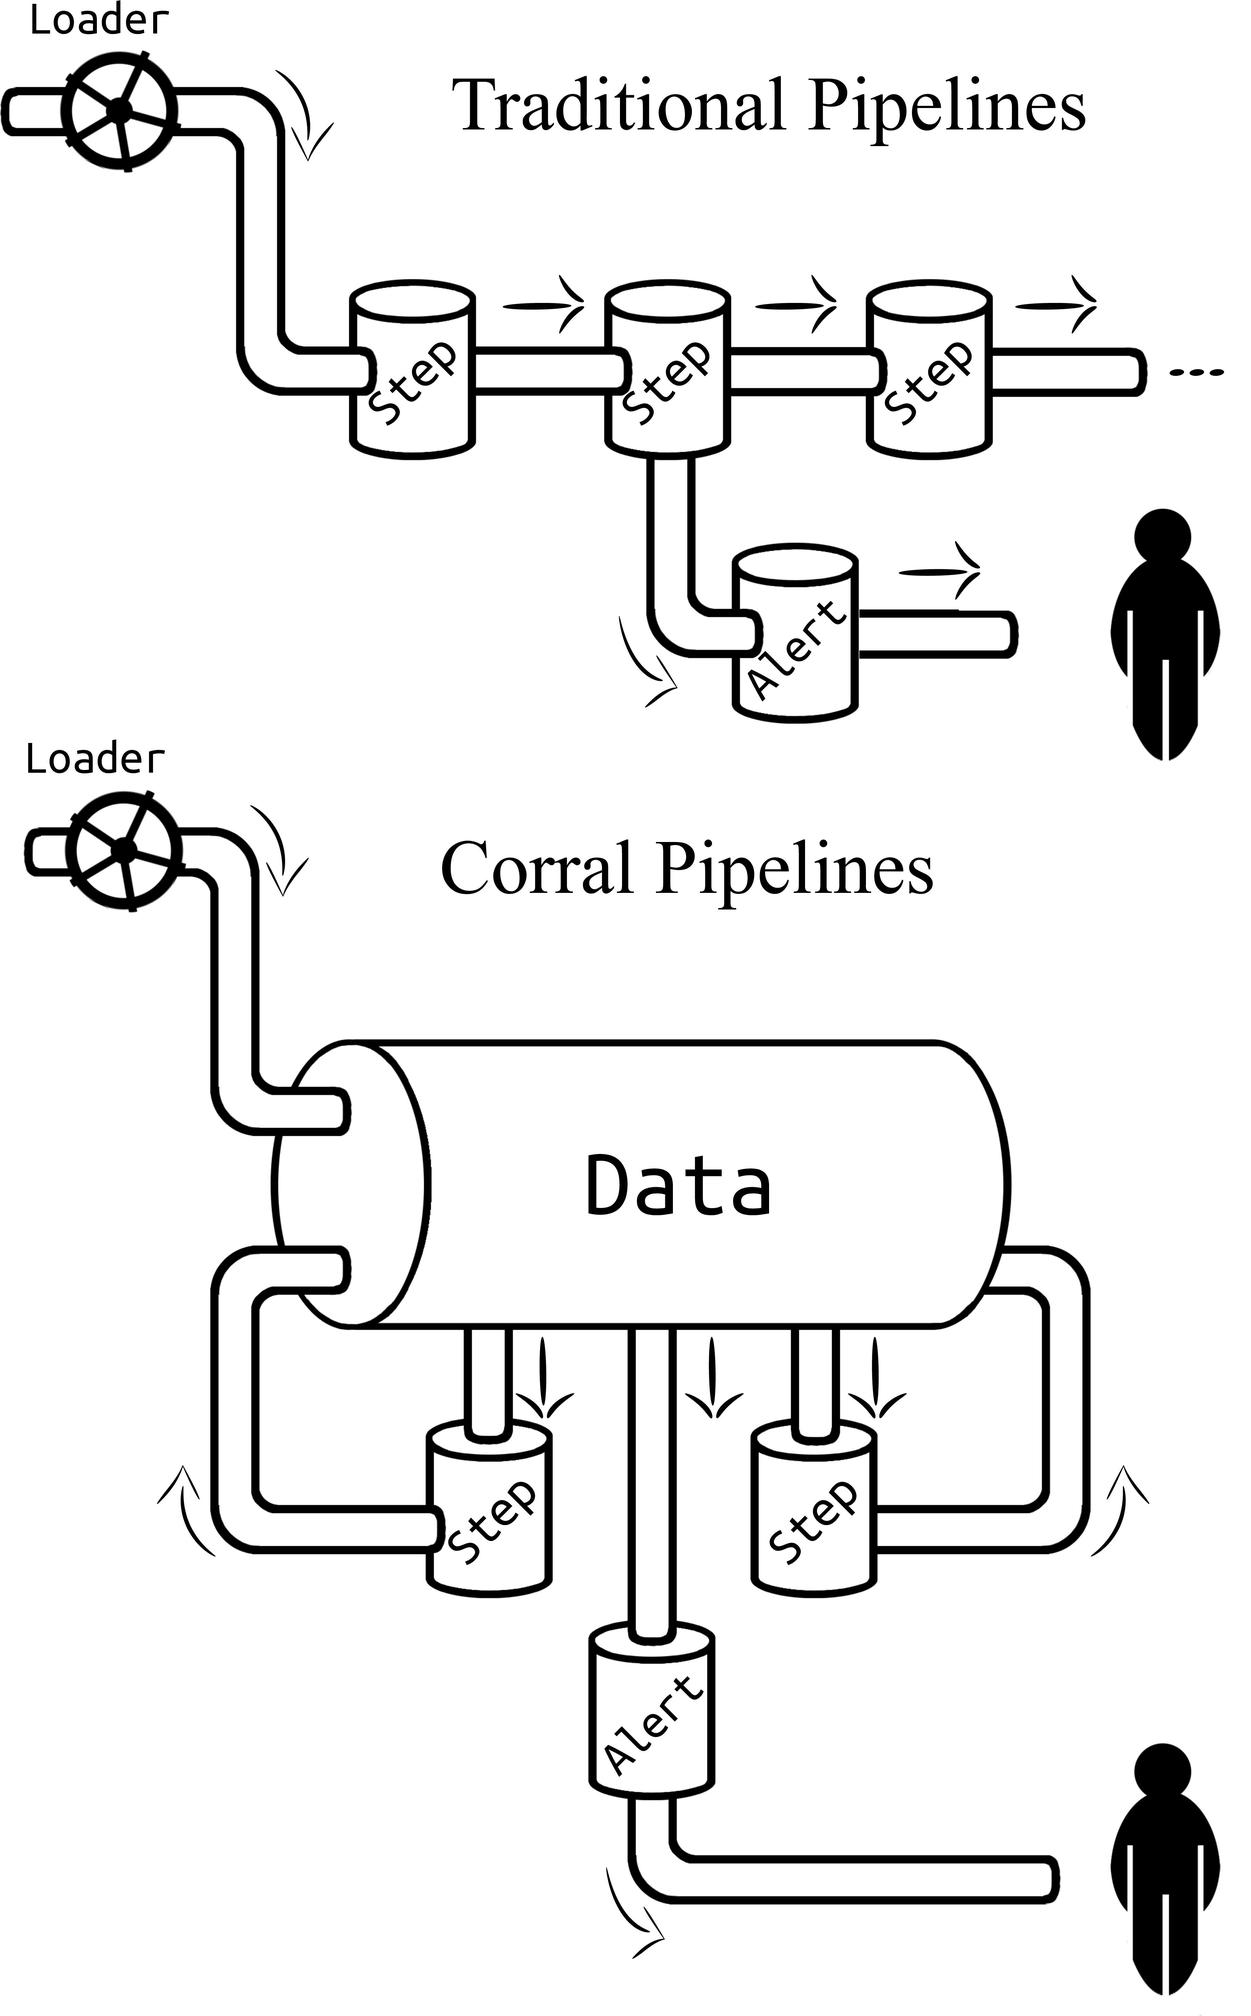What might be the drawbacks or limitations of the 'Corral Pipelines' design compared to the 'Traditional Pipelines'? While the 'Corral Pipelines' might offer improved integration, one potential drawback inferred from this design could be that it may present a single point of failure. If the centralized 'Data' component encounters issues, it has the potential to disrupt all the steps connected to it, which might not be the case in the 'Traditional Pipelines' where each step functions more autonomously. Additionally, the 'Corral Pipelines' may require more complex initial setup and infrastructure changes, making it less flexible if rapid adaptation to new processes or technologies is needed. 